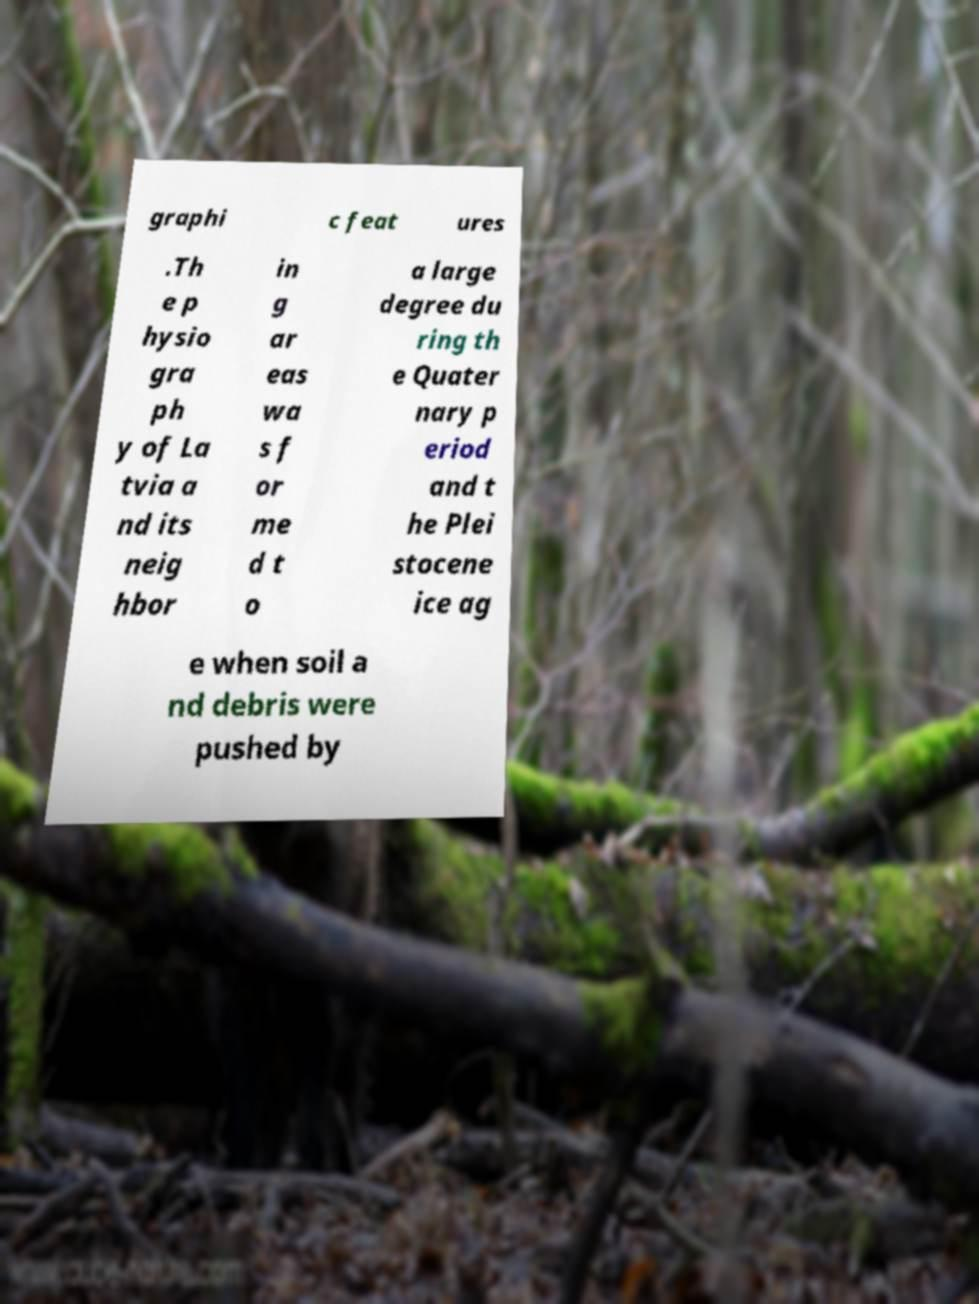I need the written content from this picture converted into text. Can you do that? graphi c feat ures .Th e p hysio gra ph y of La tvia a nd its neig hbor in g ar eas wa s f or me d t o a large degree du ring th e Quater nary p eriod and t he Plei stocene ice ag e when soil a nd debris were pushed by 